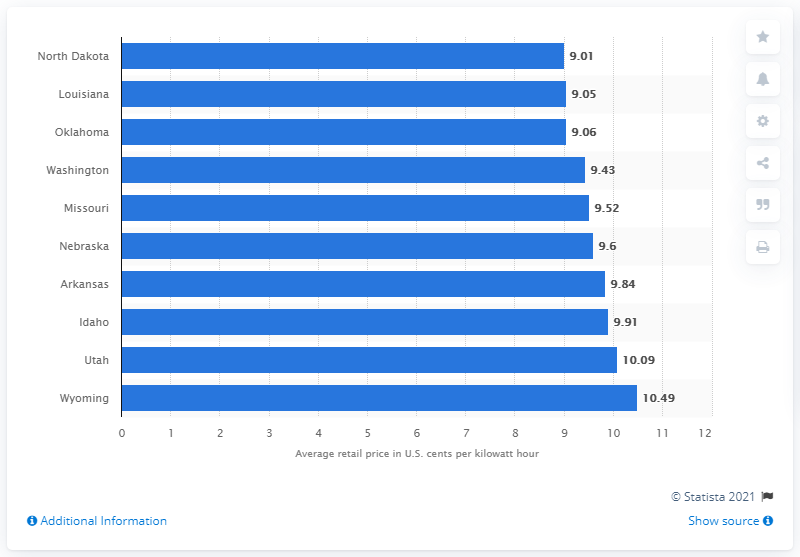Identify some key points in this picture. The average residential electricity price in Arkansas was 9.84 cents per kilowatt hour. 